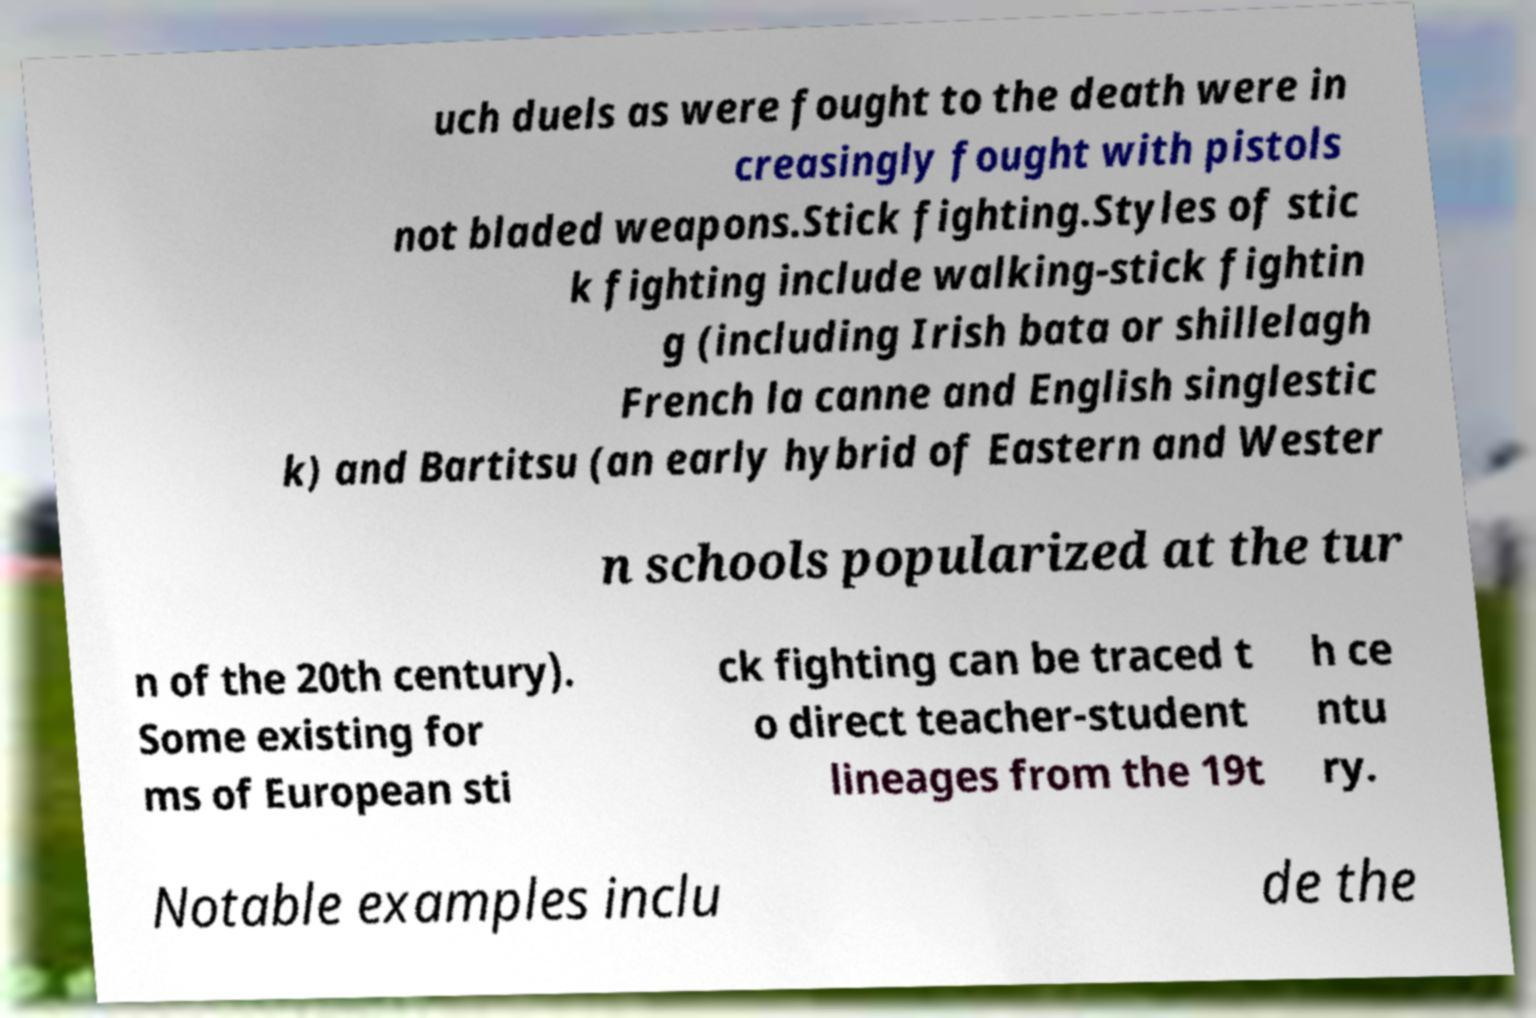What messages or text are displayed in this image? I need them in a readable, typed format. uch duels as were fought to the death were in creasingly fought with pistols not bladed weapons.Stick fighting.Styles of stic k fighting include walking-stick fightin g (including Irish bata or shillelagh French la canne and English singlestic k) and Bartitsu (an early hybrid of Eastern and Wester n schools popularized at the tur n of the 20th century). Some existing for ms of European sti ck fighting can be traced t o direct teacher-student lineages from the 19t h ce ntu ry. Notable examples inclu de the 